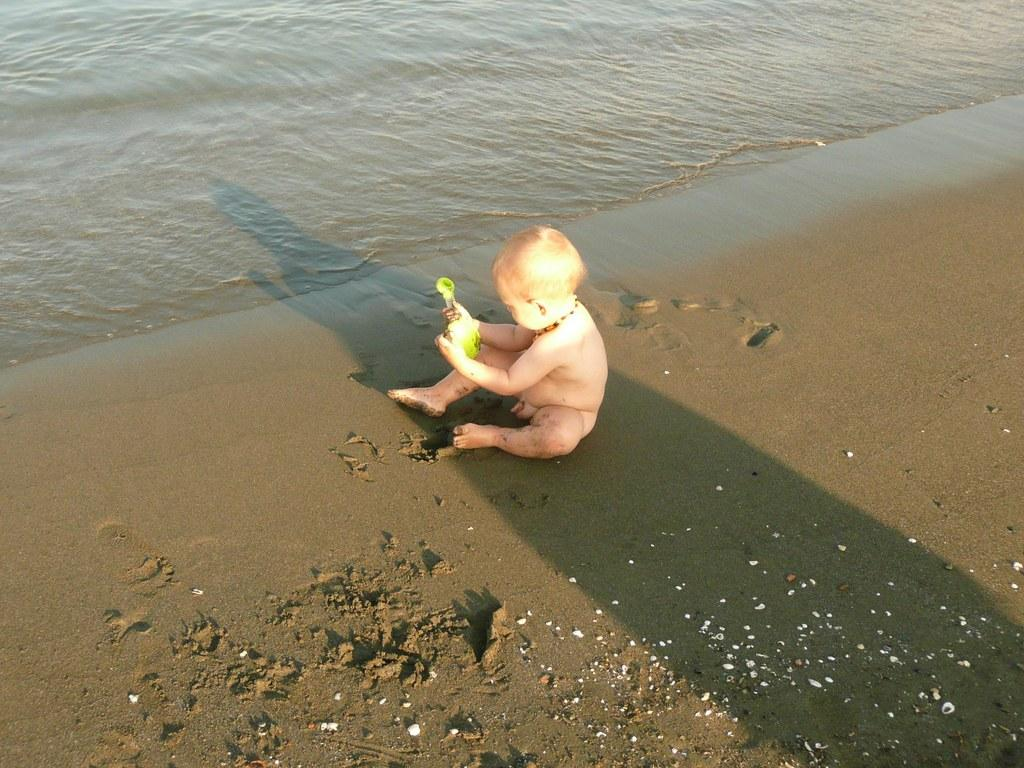Who is the main subject in the image? There is a small boy in the center of the image. What is the boy standing on? The boy is standing on a muddy floor. What can be seen at the top side of the image? There is water visible at the top side of the image. What type of honey is being used to clean the fork in the image? There is no fork or honey present in the image. How does the sleet affect the small boy in the image? There is no sleet present in the image; it only shows a small boy standing on a muddy floor with water visible at the top side. 